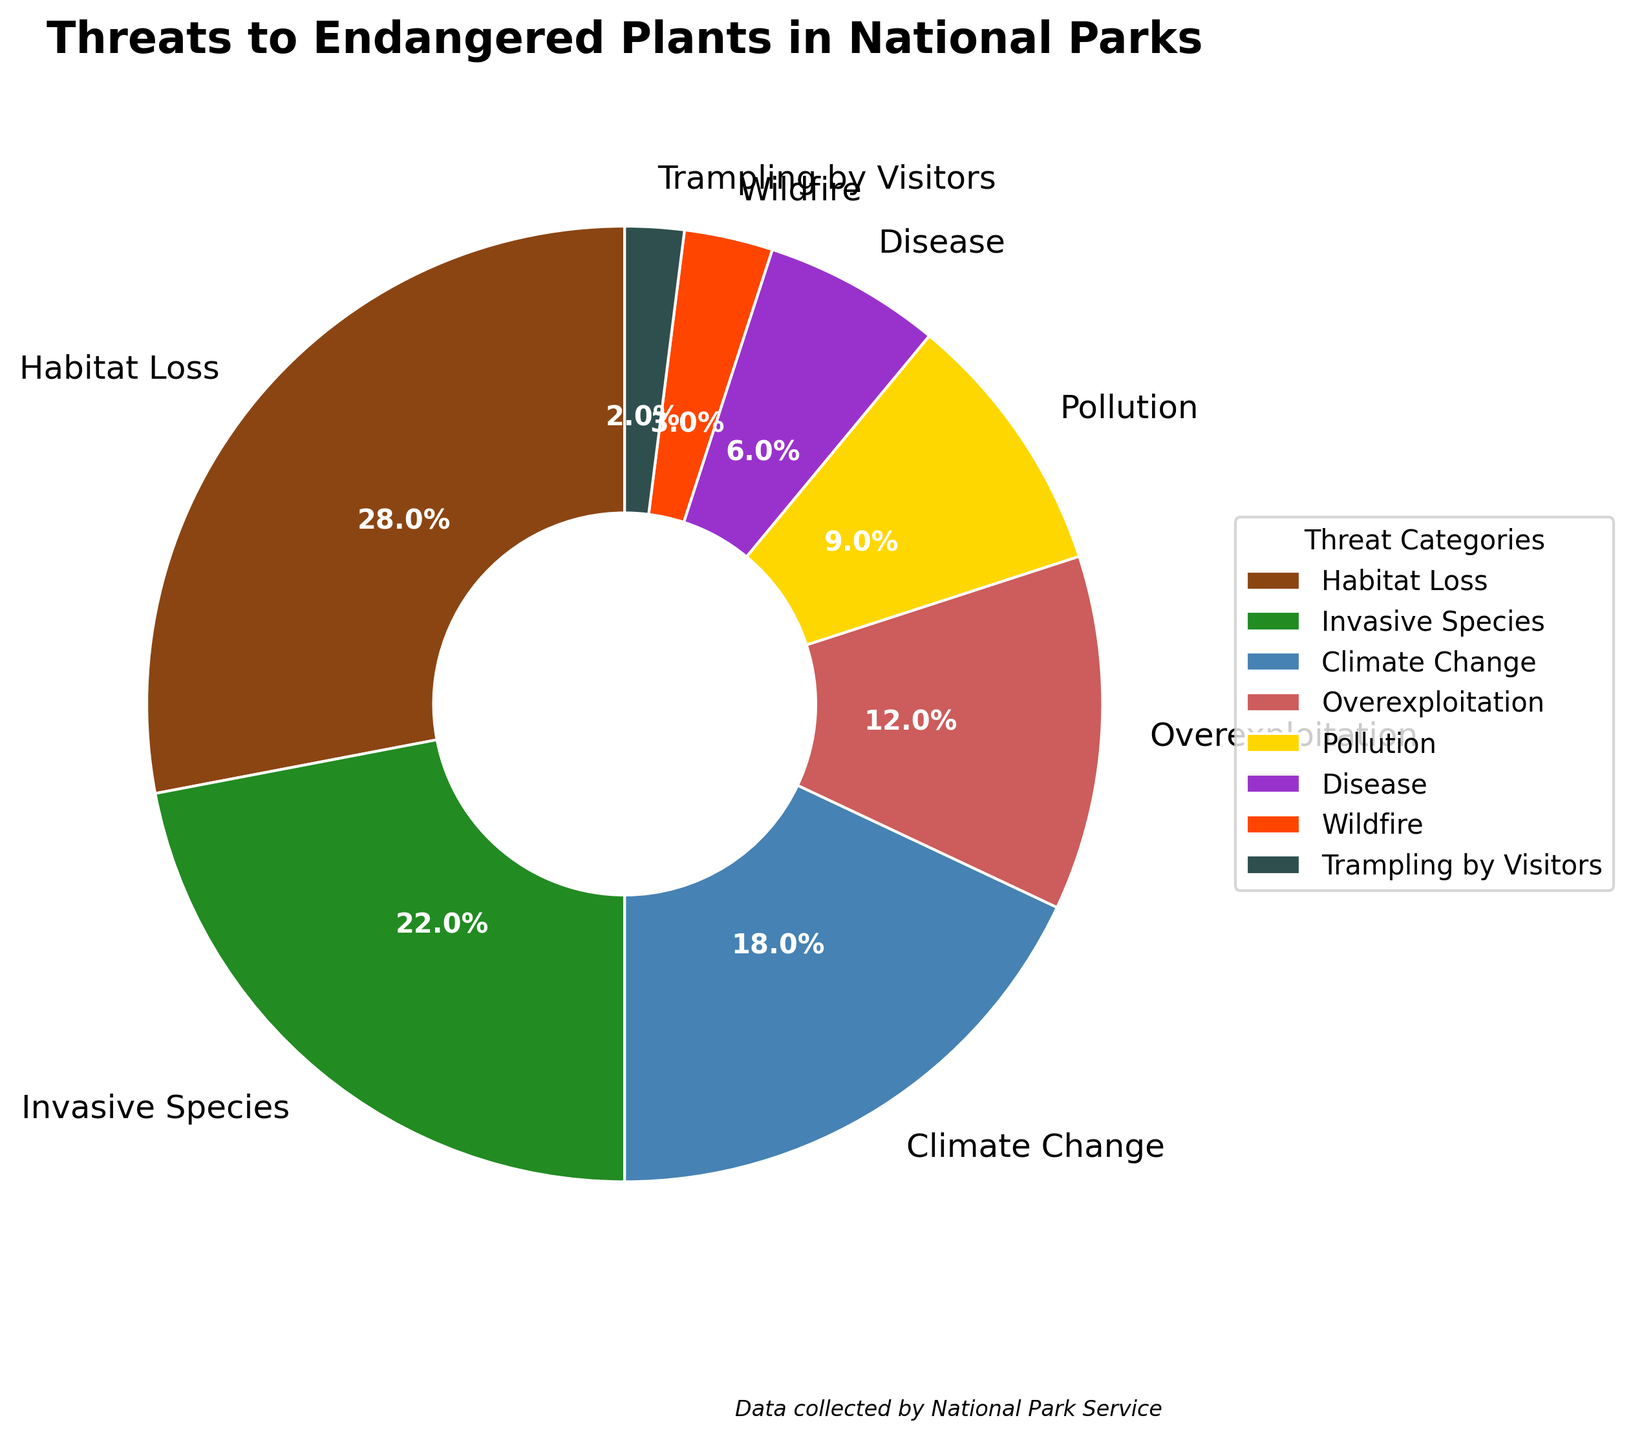What percentage of threats is contributed by both Habitat Loss and Invasive Species together? Add the percentages for Habitat Loss (28%) and Invasive Species (22%). 28 + 22 = 50
Answer: 50% Which threat has the lowest percentage? Look for the category with the smallest percentage in the pie chart. Trampling by Visitors has the lowest percentage at 2%.
Answer: Trampling by Visitors How do the percentages of Overexploitation and Disease compare? Compare the percentages for Overexploitation (12%) and Disease (6%). Overexploitation is greater than Disease.
Answer: Overexploitation > Disease What is the difference in percentage between Climate Change and Pollution? Subtract the percentage for Pollution (9%) from the percentage for Climate Change (18%). 18 - 9 = 9
Answer: 9% Which section of the pie chart is represented by the color green? Look at the pie chart and identify the color green. It represents Invasive Species.
Answer: Invasive Species If you combine the percentages of Wildfire and Trampling by Visitors, what fraction of the total threats does this combination represent? Add the percentages for Wildfire (3%) and Trampling by Visitors (2%). 3 + 2 = 5. Since the dataset is exhaustive and represents 100% of the threats, this is a fraction of 5/100.
Answer: 5/100 or 1/20 Which threat is depicted with the color red in the pie chart? Identify the color red in the pie chart. It represents Wildfire.
Answer: Wildfire Are there more threats from Overexploitation than from Pollution? Compare the percentages for Overexploitation (12%) and Pollution (9%). Yes, Overexploitation has a higher percentage than Pollution.
Answer: Yes What is the total percentage contribution of threats other than Habitat Loss? Subtract the percentage for Habitat Loss (28%) from 100%. 100 - 28 = 72
Answer: 72% How many threat categories have a percentage of more than 10%? Count the categories with percentages greater than 10%. Habitat Loss (28%), Invasive Species (22%), Climate Change (18%), and Overexploitation (12%) count as four categories.
Answer: 4 